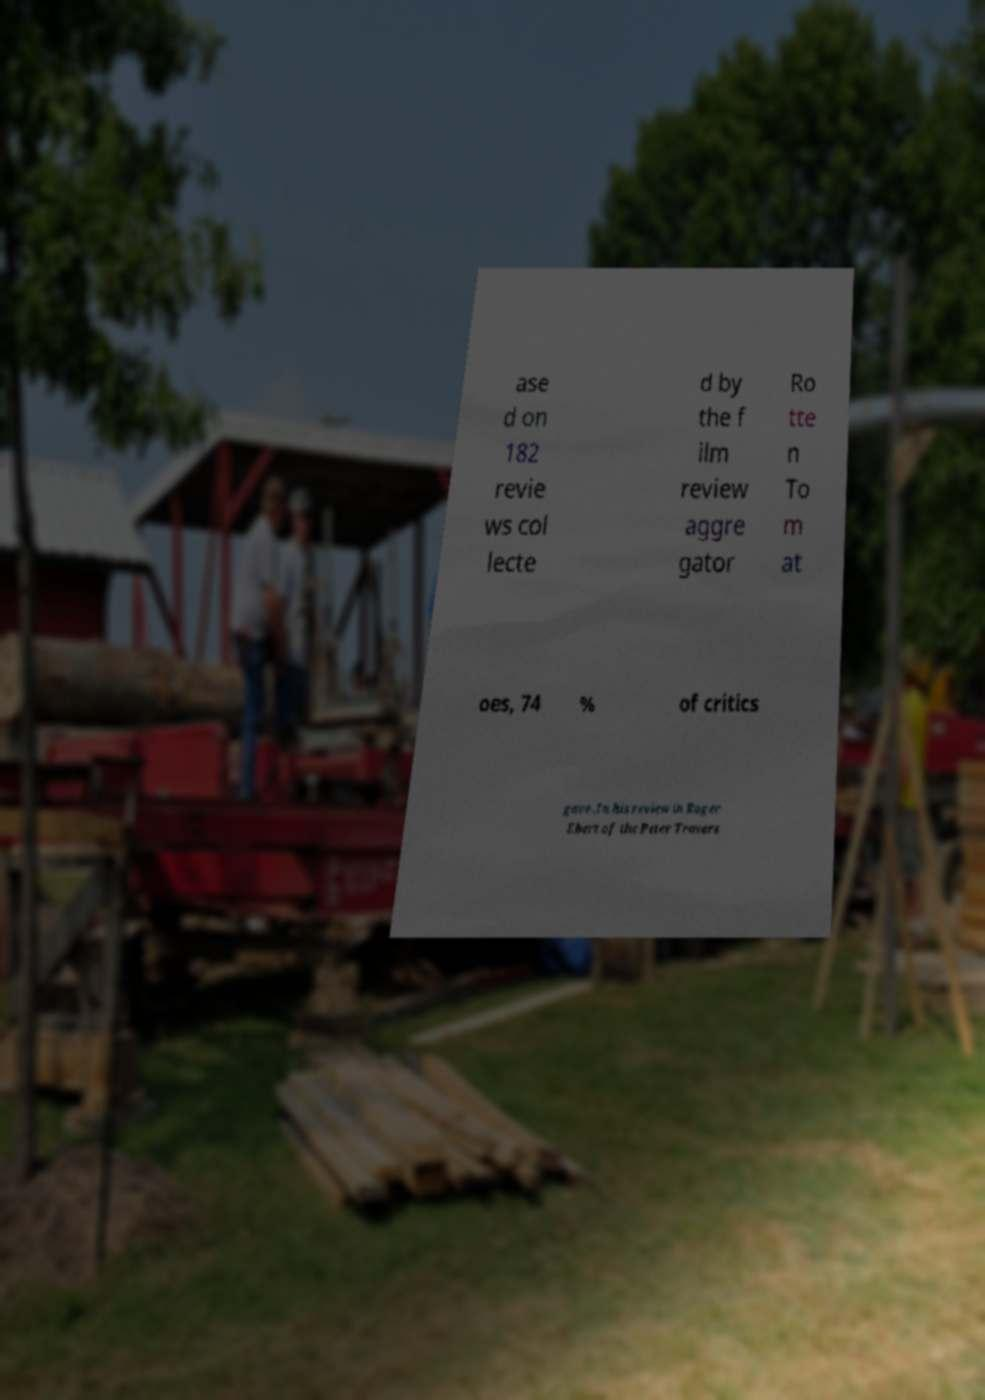There's text embedded in this image that I need extracted. Can you transcribe it verbatim? ase d on 182 revie ws col lecte d by the f ilm review aggre gator Ro tte n To m at oes, 74 % of critics gave .In his review in Roger Ebert of the Peter Travers 